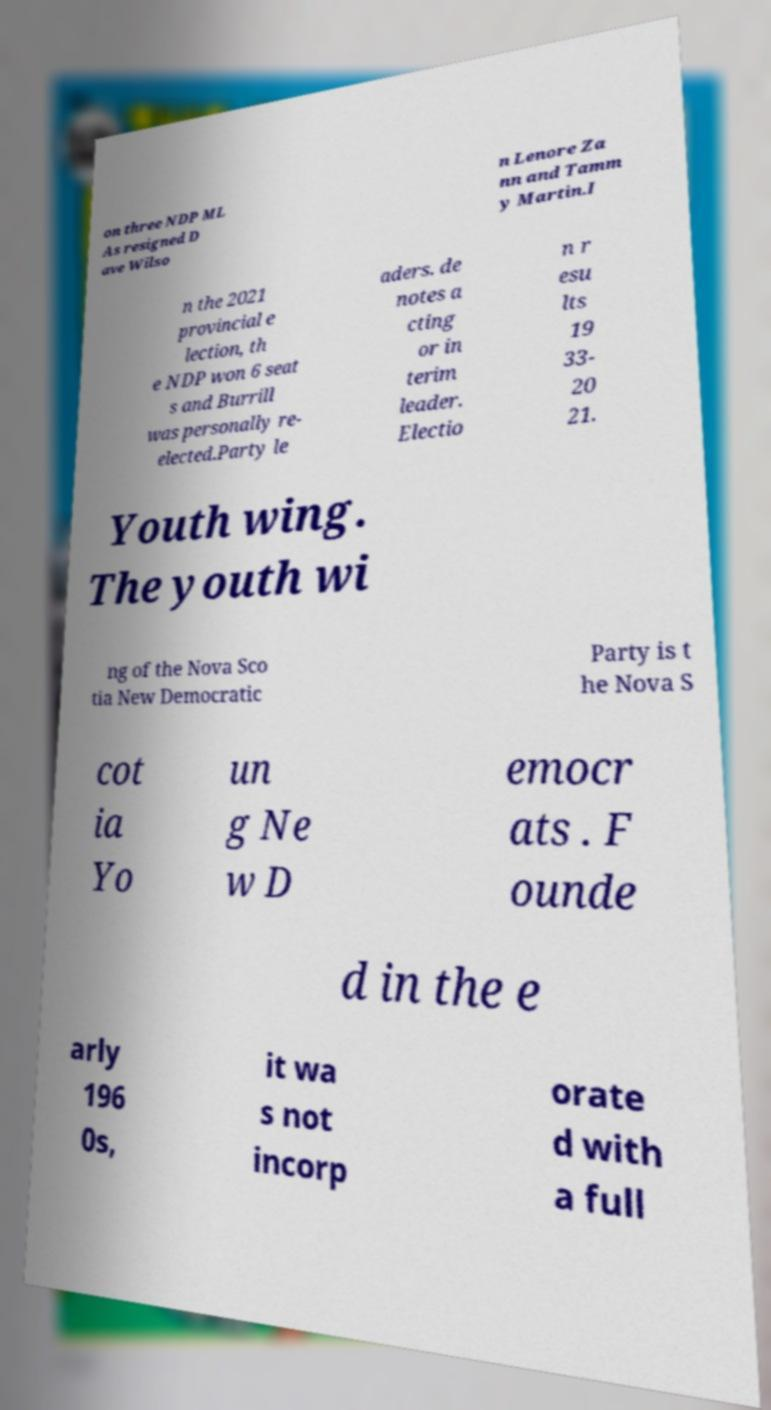Can you accurately transcribe the text from the provided image for me? on three NDP ML As resigned D ave Wilso n Lenore Za nn and Tamm y Martin.I n the 2021 provincial e lection, th e NDP won 6 seat s and Burrill was personally re- elected.Party le aders. de notes a cting or in terim leader. Electio n r esu lts 19 33- 20 21. Youth wing. The youth wi ng of the Nova Sco tia New Democratic Party is t he Nova S cot ia Yo un g Ne w D emocr ats . F ounde d in the e arly 196 0s, it wa s not incorp orate d with a full 